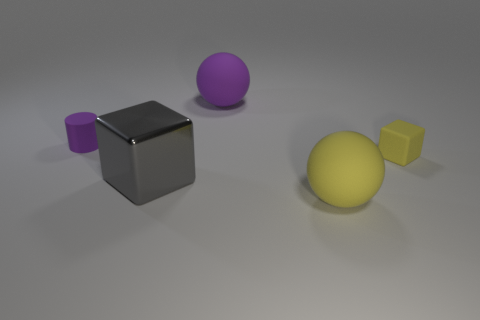What size is the matte object that is the same color as the small cylinder?
Your response must be concise. Large. What is the material of the sphere that is the same color as the tiny matte cube?
Keep it short and to the point. Rubber. There is a matte object that is both behind the small yellow rubber thing and to the right of the gray block; what shape is it?
Your response must be concise. Sphere. There is a small cube that is made of the same material as the small purple thing; what color is it?
Ensure brevity in your answer.  Yellow. Is the number of small yellow blocks that are in front of the yellow ball the same as the number of big gray rubber balls?
Offer a very short reply. Yes. There is a purple matte object that is the same size as the yellow rubber block; what shape is it?
Ensure brevity in your answer.  Cylinder. How many other objects are the same shape as the gray thing?
Provide a succinct answer. 1. There is a gray metallic block; is it the same size as the sphere in front of the tiny yellow rubber cube?
Make the answer very short. Yes. How many objects are either purple matte things to the right of the gray thing or red balls?
Offer a terse response. 1. What shape is the large object behind the rubber cylinder?
Give a very brief answer. Sphere. 